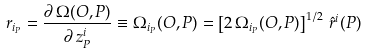Convert formula to latex. <formula><loc_0><loc_0><loc_500><loc_500>r _ { i _ { P } } = \frac { \partial \, \Omega ( O , P ) } { \partial \, z ^ { i } _ { P } } \equiv \Omega _ { i _ { P } } ( O , P ) = \left [ 2 \, \Omega _ { i _ { P } } ( O , P ) \right ] ^ { 1 / 2 } \, \hat { r } ^ { i } ( P )</formula> 